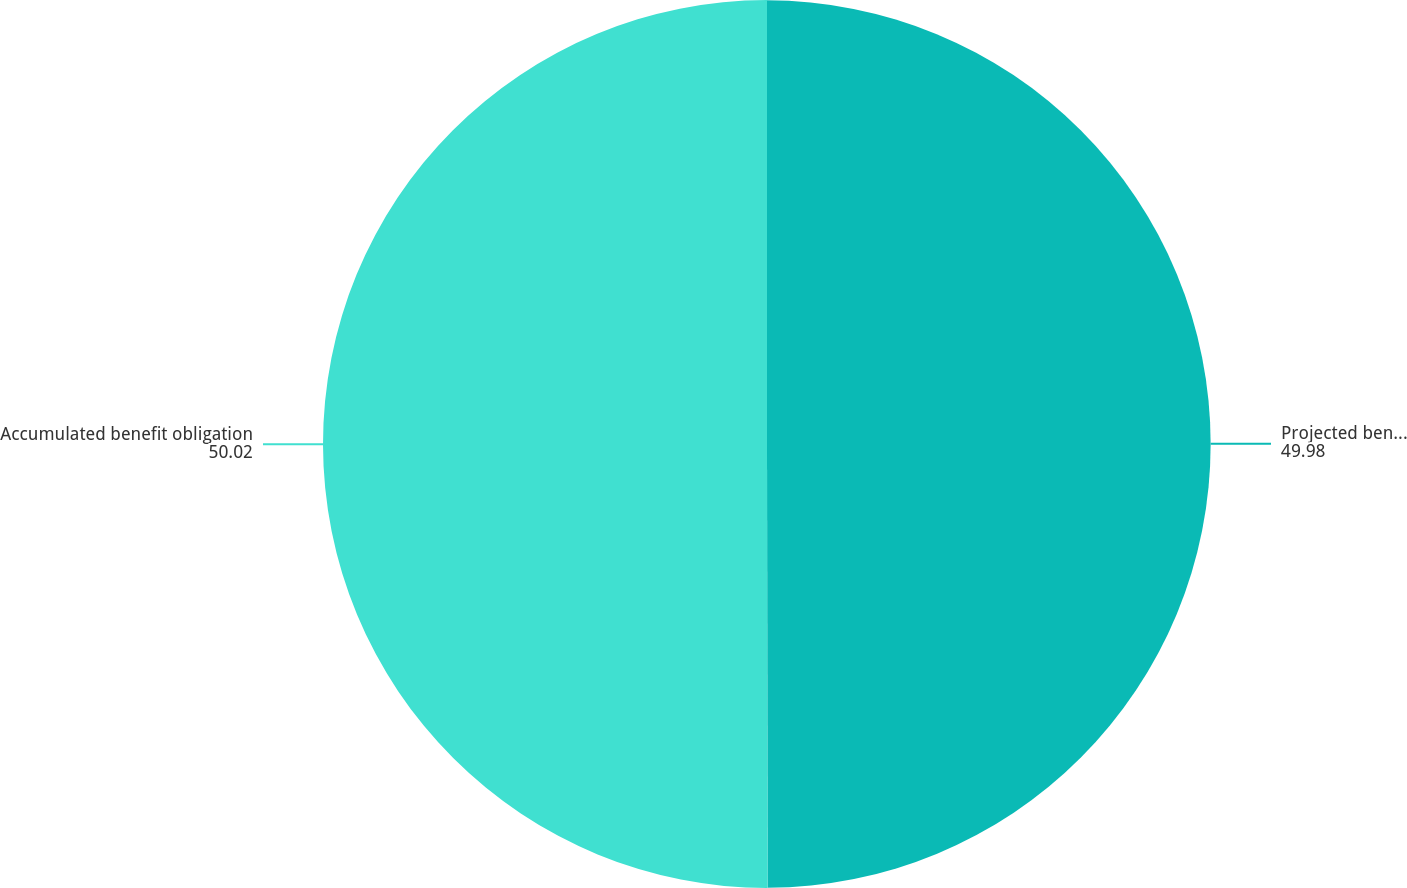Convert chart. <chart><loc_0><loc_0><loc_500><loc_500><pie_chart><fcel>Projected benefit obligation<fcel>Accumulated benefit obligation<nl><fcel>49.98%<fcel>50.02%<nl></chart> 